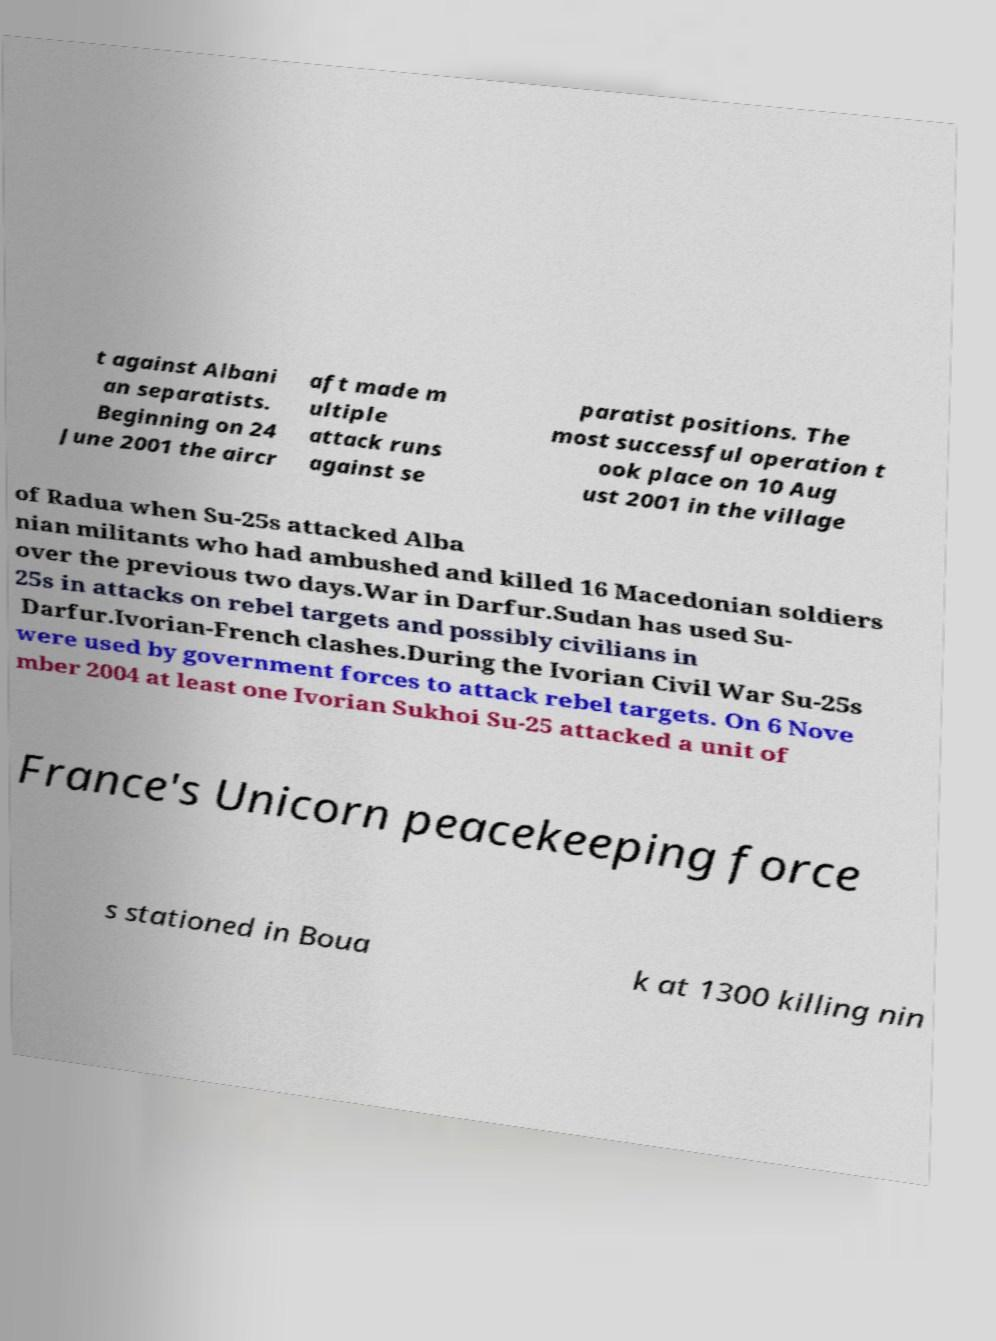I need the written content from this picture converted into text. Can you do that? t against Albani an separatists. Beginning on 24 June 2001 the aircr aft made m ultiple attack runs against se paratist positions. The most successful operation t ook place on 10 Aug ust 2001 in the village of Radua when Su-25s attacked Alba nian militants who had ambushed and killed 16 Macedonian soldiers over the previous two days.War in Darfur.Sudan has used Su- 25s in attacks on rebel targets and possibly civilians in Darfur.Ivorian-French clashes.During the Ivorian Civil War Su-25s were used by government forces to attack rebel targets. On 6 Nove mber 2004 at least one Ivorian Sukhoi Su-25 attacked a unit of France's Unicorn peacekeeping force s stationed in Boua k at 1300 killing nin 